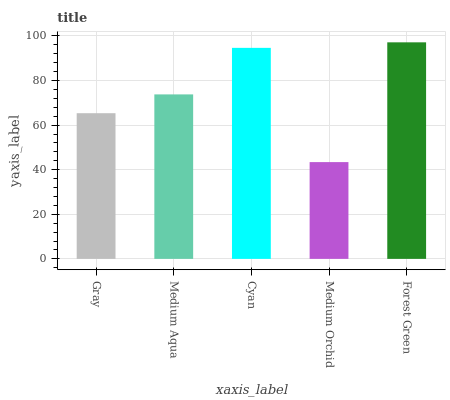Is Medium Aqua the minimum?
Answer yes or no. No. Is Medium Aqua the maximum?
Answer yes or no. No. Is Medium Aqua greater than Gray?
Answer yes or no. Yes. Is Gray less than Medium Aqua?
Answer yes or no. Yes. Is Gray greater than Medium Aqua?
Answer yes or no. No. Is Medium Aqua less than Gray?
Answer yes or no. No. Is Medium Aqua the high median?
Answer yes or no. Yes. Is Medium Aqua the low median?
Answer yes or no. Yes. Is Gray the high median?
Answer yes or no. No. Is Gray the low median?
Answer yes or no. No. 